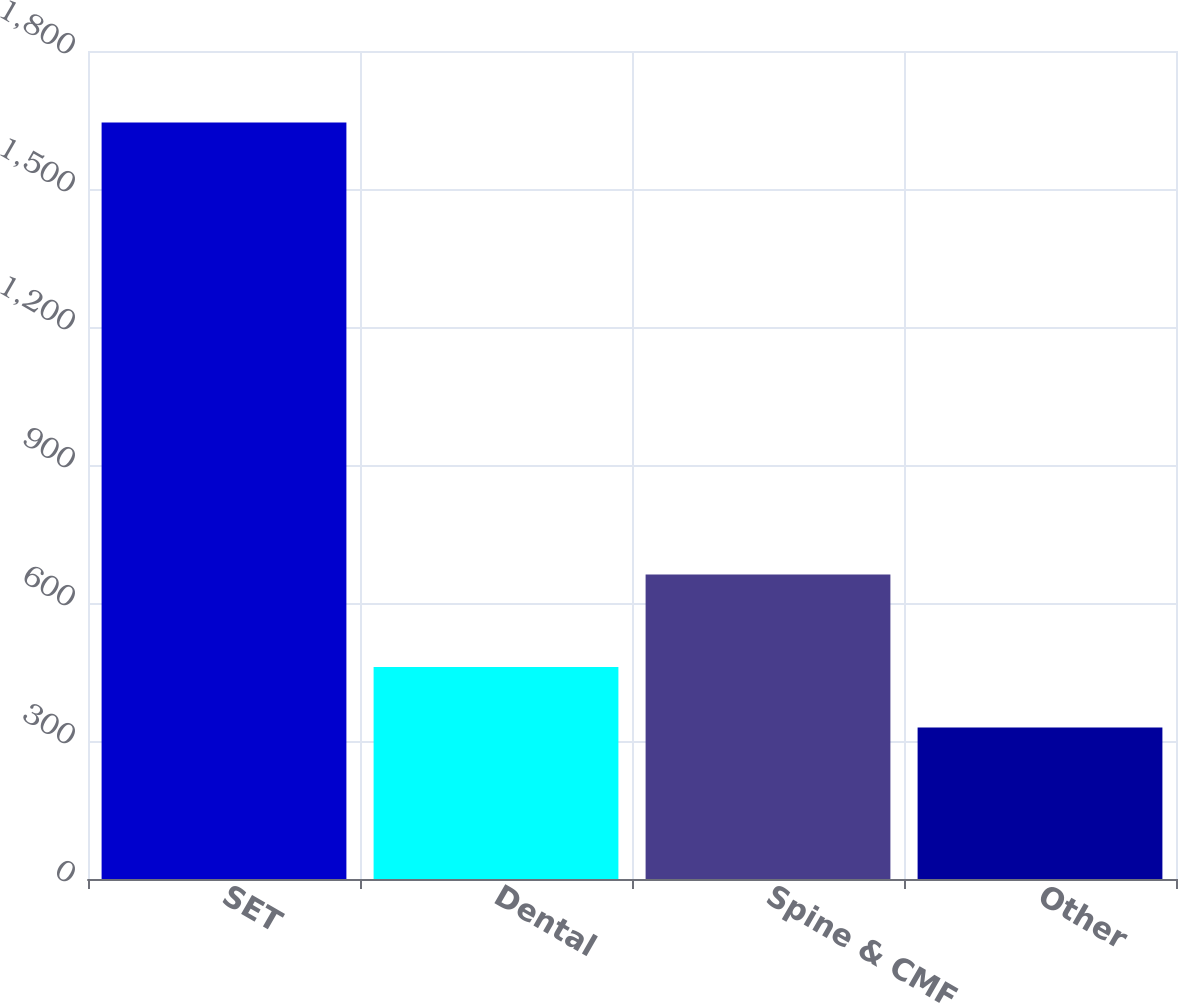Convert chart to OTSL. <chart><loc_0><loc_0><loc_500><loc_500><bar_chart><fcel>SET<fcel>Dental<fcel>Spine & CMF<fcel>Other<nl><fcel>1644.4<fcel>460.63<fcel>662<fcel>329.1<nl></chart> 